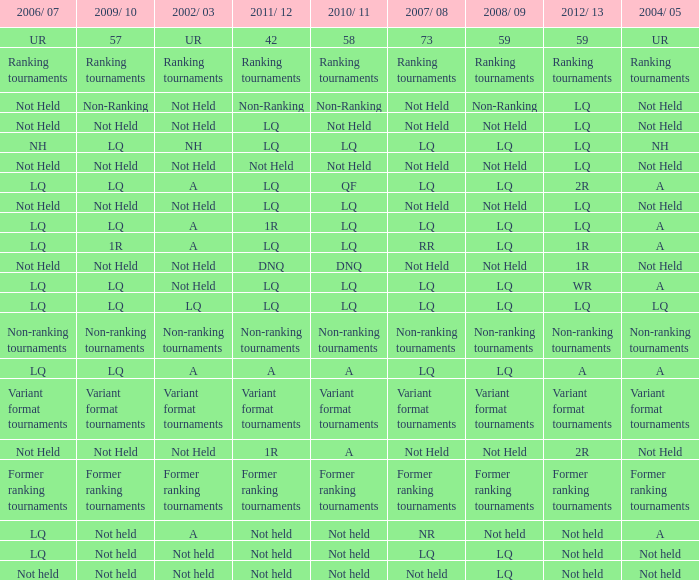Name the 2009/10 with 2011/12 of lq and 2008/09 of not held Not Held, Not Held. 